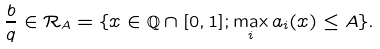<formula> <loc_0><loc_0><loc_500><loc_500>\frac { b } { q } \in \mathcal { R } _ { A } = \{ x \in \mathbb { Q } \cap [ 0 , 1 ] ; \max _ { i } a _ { i } ( x ) \leq A \} .</formula> 